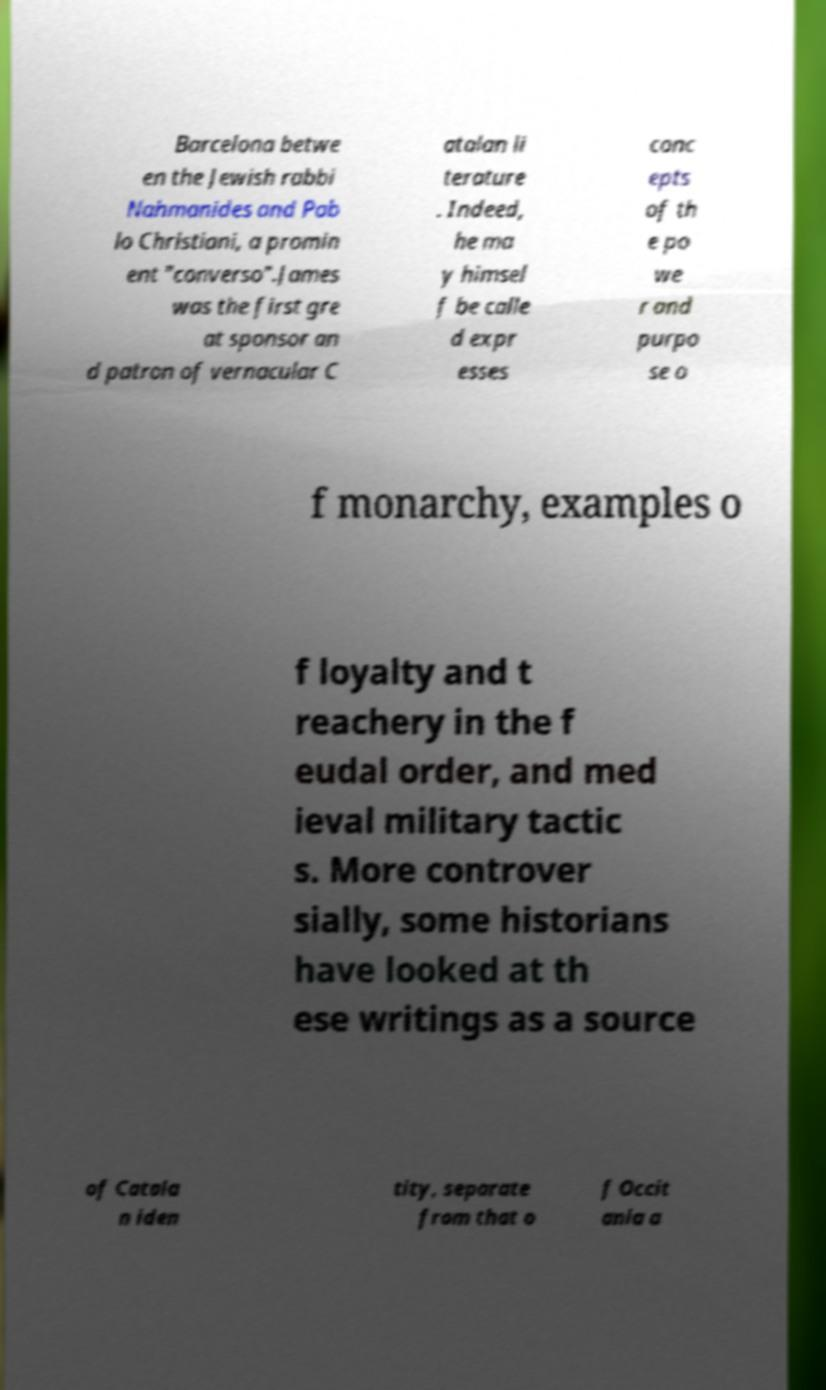Could you assist in decoding the text presented in this image and type it out clearly? Barcelona betwe en the Jewish rabbi Nahmanides and Pab lo Christiani, a promin ent "converso".James was the first gre at sponsor an d patron of vernacular C atalan li terature . Indeed, he ma y himsel f be calle d expr esses conc epts of th e po we r and purpo se o f monarchy, examples o f loyalty and t reachery in the f eudal order, and med ieval military tactic s. More controver sially, some historians have looked at th ese writings as a source of Catala n iden tity, separate from that o f Occit ania a 